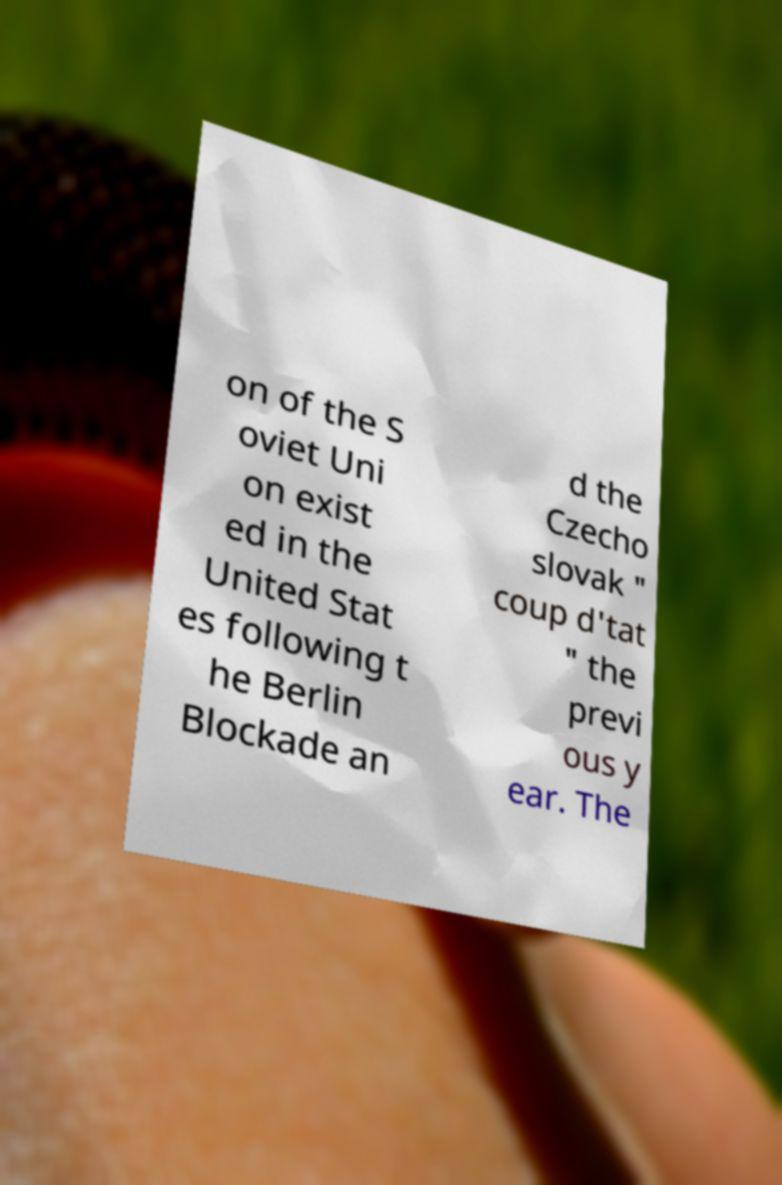Could you assist in decoding the text presented in this image and type it out clearly? on of the S oviet Uni on exist ed in the United Stat es following t he Berlin Blockade an d the Czecho slovak " coup d'tat " the previ ous y ear. The 